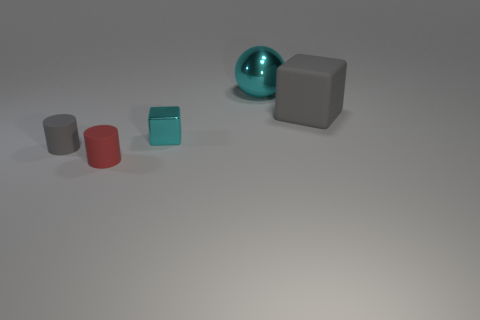Are there any other things that have the same shape as the big shiny object?
Make the answer very short. No. What number of things are small objects on the right side of the gray rubber cylinder or gray objects in front of the gray rubber cube?
Offer a very short reply. 3. There is a shiny thing left of the sphere; is there a cyan block that is in front of it?
Give a very brief answer. No. There is a gray thing that is the same size as the metallic block; what shape is it?
Your response must be concise. Cylinder. What number of objects are cyan metal objects behind the large matte block or red matte things?
Provide a short and direct response. 2. What number of other objects are the same material as the gray block?
Make the answer very short. 2. There is a object that is the same color as the big matte block; what shape is it?
Provide a short and direct response. Cylinder. What is the size of the cyan metallic object that is left of the large cyan ball?
Offer a very short reply. Small. There is a object that is the same material as the tiny cyan cube; what is its shape?
Your response must be concise. Sphere. Does the tiny cyan object have the same material as the gray thing that is on the right side of the big cyan thing?
Offer a very short reply. No. 